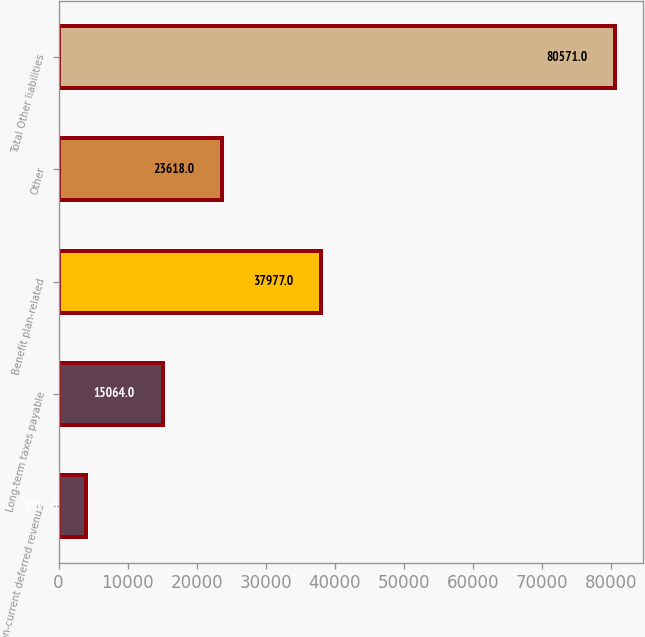Convert chart to OTSL. <chart><loc_0><loc_0><loc_500><loc_500><bar_chart><fcel>Non-current deferred revenue<fcel>Long-term taxes payable<fcel>Benefit plan-related<fcel>Other<fcel>Total Other liabilities<nl><fcel>3912<fcel>15064<fcel>37977<fcel>23618<fcel>80571<nl></chart> 